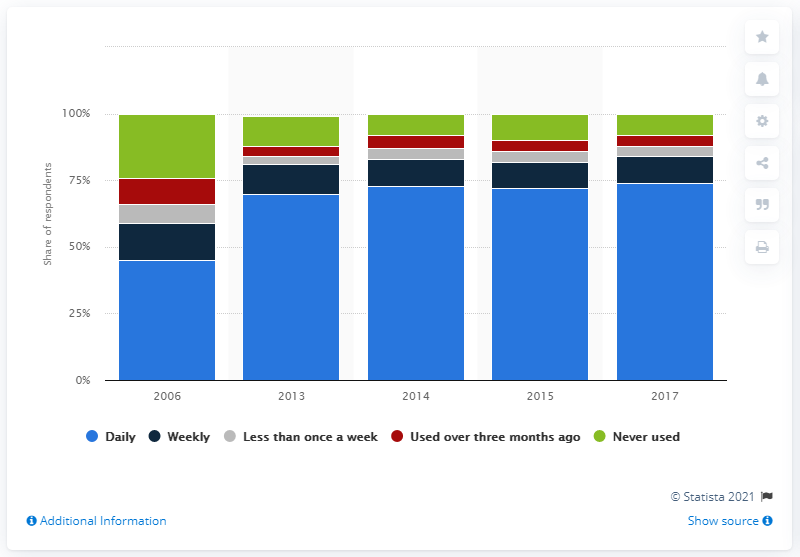Mention a couple of crucial points in this snapshot. The last time computers were utilized in Great Britain was in the year 2017. In 2006, the frequency of computer usage in Great Britain was measured. 